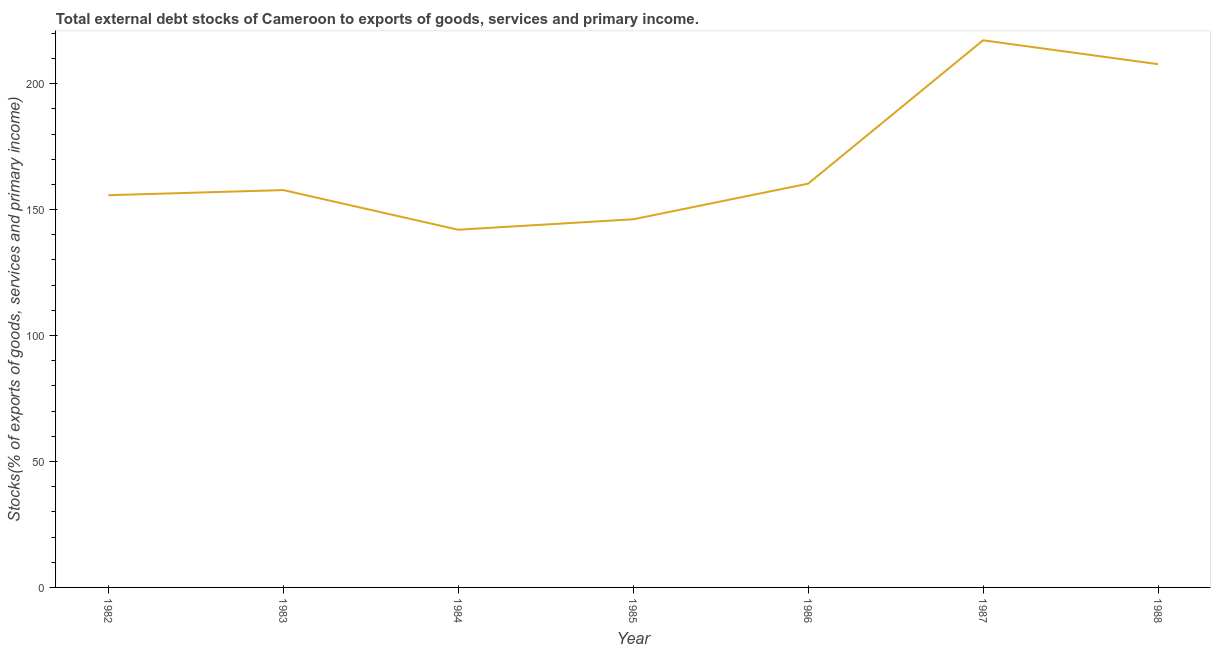What is the external debt stocks in 1983?
Offer a very short reply. 157.75. Across all years, what is the maximum external debt stocks?
Provide a short and direct response. 217.21. Across all years, what is the minimum external debt stocks?
Your answer should be compact. 142.01. What is the sum of the external debt stocks?
Provide a short and direct response. 1186.86. What is the difference between the external debt stocks in 1983 and 1988?
Offer a very short reply. -49.99. What is the average external debt stocks per year?
Your answer should be compact. 169.55. What is the median external debt stocks?
Your answer should be very brief. 157.75. What is the ratio of the external debt stocks in 1984 to that in 1986?
Your response must be concise. 0.89. Is the external debt stocks in 1984 less than that in 1986?
Your answer should be compact. Yes. What is the difference between the highest and the second highest external debt stocks?
Give a very brief answer. 9.47. What is the difference between the highest and the lowest external debt stocks?
Offer a terse response. 75.2. In how many years, is the external debt stocks greater than the average external debt stocks taken over all years?
Offer a terse response. 2. How many years are there in the graph?
Offer a terse response. 7. Does the graph contain any zero values?
Keep it short and to the point. No. Does the graph contain grids?
Provide a succinct answer. No. What is the title of the graph?
Offer a very short reply. Total external debt stocks of Cameroon to exports of goods, services and primary income. What is the label or title of the X-axis?
Your answer should be very brief. Year. What is the label or title of the Y-axis?
Keep it short and to the point. Stocks(% of exports of goods, services and primary income). What is the Stocks(% of exports of goods, services and primary income) of 1982?
Your answer should be compact. 155.71. What is the Stocks(% of exports of goods, services and primary income) in 1983?
Offer a very short reply. 157.75. What is the Stocks(% of exports of goods, services and primary income) of 1984?
Give a very brief answer. 142.01. What is the Stocks(% of exports of goods, services and primary income) of 1985?
Keep it short and to the point. 146.16. What is the Stocks(% of exports of goods, services and primary income) of 1986?
Your answer should be compact. 160.29. What is the Stocks(% of exports of goods, services and primary income) of 1987?
Provide a succinct answer. 217.21. What is the Stocks(% of exports of goods, services and primary income) in 1988?
Provide a short and direct response. 207.73. What is the difference between the Stocks(% of exports of goods, services and primary income) in 1982 and 1983?
Your answer should be compact. -2.03. What is the difference between the Stocks(% of exports of goods, services and primary income) in 1982 and 1984?
Provide a short and direct response. 13.71. What is the difference between the Stocks(% of exports of goods, services and primary income) in 1982 and 1985?
Provide a short and direct response. 9.56. What is the difference between the Stocks(% of exports of goods, services and primary income) in 1982 and 1986?
Your answer should be very brief. -4.58. What is the difference between the Stocks(% of exports of goods, services and primary income) in 1982 and 1987?
Offer a terse response. -61.49. What is the difference between the Stocks(% of exports of goods, services and primary income) in 1982 and 1988?
Provide a short and direct response. -52.02. What is the difference between the Stocks(% of exports of goods, services and primary income) in 1983 and 1984?
Your answer should be very brief. 15.74. What is the difference between the Stocks(% of exports of goods, services and primary income) in 1983 and 1985?
Provide a short and direct response. 11.59. What is the difference between the Stocks(% of exports of goods, services and primary income) in 1983 and 1986?
Ensure brevity in your answer.  -2.55. What is the difference between the Stocks(% of exports of goods, services and primary income) in 1983 and 1987?
Ensure brevity in your answer.  -59.46. What is the difference between the Stocks(% of exports of goods, services and primary income) in 1983 and 1988?
Your response must be concise. -49.99. What is the difference between the Stocks(% of exports of goods, services and primary income) in 1984 and 1985?
Offer a terse response. -4.15. What is the difference between the Stocks(% of exports of goods, services and primary income) in 1984 and 1986?
Ensure brevity in your answer.  -18.28. What is the difference between the Stocks(% of exports of goods, services and primary income) in 1984 and 1987?
Provide a short and direct response. -75.2. What is the difference between the Stocks(% of exports of goods, services and primary income) in 1984 and 1988?
Ensure brevity in your answer.  -65.73. What is the difference between the Stocks(% of exports of goods, services and primary income) in 1985 and 1986?
Ensure brevity in your answer.  -14.14. What is the difference between the Stocks(% of exports of goods, services and primary income) in 1985 and 1987?
Your answer should be compact. -71.05. What is the difference between the Stocks(% of exports of goods, services and primary income) in 1985 and 1988?
Make the answer very short. -61.58. What is the difference between the Stocks(% of exports of goods, services and primary income) in 1986 and 1987?
Keep it short and to the point. -56.92. What is the difference between the Stocks(% of exports of goods, services and primary income) in 1986 and 1988?
Ensure brevity in your answer.  -47.44. What is the difference between the Stocks(% of exports of goods, services and primary income) in 1987 and 1988?
Offer a very short reply. 9.47. What is the ratio of the Stocks(% of exports of goods, services and primary income) in 1982 to that in 1983?
Your answer should be compact. 0.99. What is the ratio of the Stocks(% of exports of goods, services and primary income) in 1982 to that in 1984?
Your answer should be very brief. 1.1. What is the ratio of the Stocks(% of exports of goods, services and primary income) in 1982 to that in 1985?
Your response must be concise. 1.06. What is the ratio of the Stocks(% of exports of goods, services and primary income) in 1982 to that in 1987?
Your answer should be very brief. 0.72. What is the ratio of the Stocks(% of exports of goods, services and primary income) in 1982 to that in 1988?
Your answer should be compact. 0.75. What is the ratio of the Stocks(% of exports of goods, services and primary income) in 1983 to that in 1984?
Keep it short and to the point. 1.11. What is the ratio of the Stocks(% of exports of goods, services and primary income) in 1983 to that in 1985?
Keep it short and to the point. 1.08. What is the ratio of the Stocks(% of exports of goods, services and primary income) in 1983 to that in 1987?
Offer a very short reply. 0.73. What is the ratio of the Stocks(% of exports of goods, services and primary income) in 1983 to that in 1988?
Keep it short and to the point. 0.76. What is the ratio of the Stocks(% of exports of goods, services and primary income) in 1984 to that in 1985?
Your response must be concise. 0.97. What is the ratio of the Stocks(% of exports of goods, services and primary income) in 1984 to that in 1986?
Keep it short and to the point. 0.89. What is the ratio of the Stocks(% of exports of goods, services and primary income) in 1984 to that in 1987?
Offer a terse response. 0.65. What is the ratio of the Stocks(% of exports of goods, services and primary income) in 1984 to that in 1988?
Offer a terse response. 0.68. What is the ratio of the Stocks(% of exports of goods, services and primary income) in 1985 to that in 1986?
Provide a succinct answer. 0.91. What is the ratio of the Stocks(% of exports of goods, services and primary income) in 1985 to that in 1987?
Offer a terse response. 0.67. What is the ratio of the Stocks(% of exports of goods, services and primary income) in 1985 to that in 1988?
Offer a terse response. 0.7. What is the ratio of the Stocks(% of exports of goods, services and primary income) in 1986 to that in 1987?
Ensure brevity in your answer.  0.74. What is the ratio of the Stocks(% of exports of goods, services and primary income) in 1986 to that in 1988?
Ensure brevity in your answer.  0.77. What is the ratio of the Stocks(% of exports of goods, services and primary income) in 1987 to that in 1988?
Give a very brief answer. 1.05. 